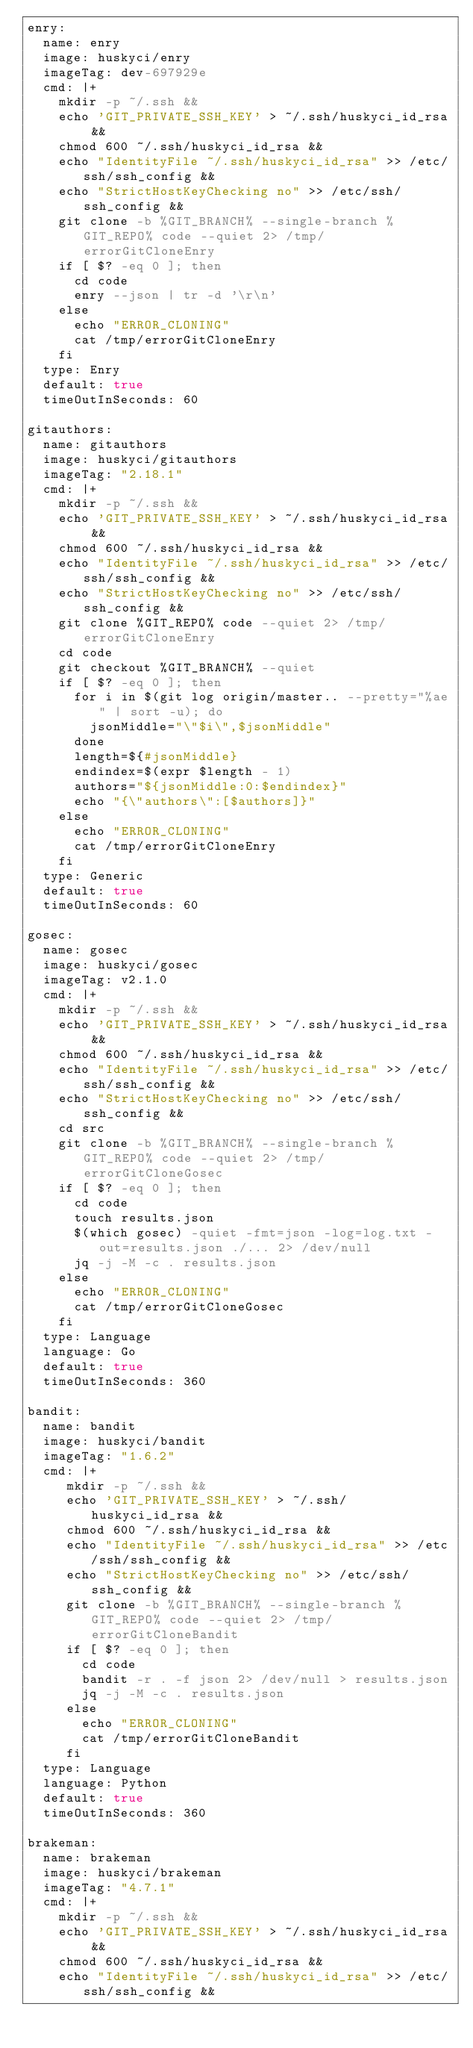<code> <loc_0><loc_0><loc_500><loc_500><_YAML_>enry:
  name: enry
  image: huskyci/enry
  imageTag: dev-697929e
  cmd: |+
    mkdir -p ~/.ssh &&
    echo 'GIT_PRIVATE_SSH_KEY' > ~/.ssh/huskyci_id_rsa &&
    chmod 600 ~/.ssh/huskyci_id_rsa &&
    echo "IdentityFile ~/.ssh/huskyci_id_rsa" >> /etc/ssh/ssh_config &&
    echo "StrictHostKeyChecking no" >> /etc/ssh/ssh_config &&
    git clone -b %GIT_BRANCH% --single-branch %GIT_REPO% code --quiet 2> /tmp/errorGitCloneEnry
    if [ $? -eq 0 ]; then
      cd code
      enry --json | tr -d '\r\n'
    else
      echo "ERROR_CLONING"
      cat /tmp/errorGitCloneEnry
    fi
  type: Enry
  default: true
  timeOutInSeconds: 60

gitauthors:
  name: gitauthors
  image: huskyci/gitauthors
  imageTag: "2.18.1"
  cmd: |+
    mkdir -p ~/.ssh &&
    echo 'GIT_PRIVATE_SSH_KEY' > ~/.ssh/huskyci_id_rsa &&
    chmod 600 ~/.ssh/huskyci_id_rsa &&
    echo "IdentityFile ~/.ssh/huskyci_id_rsa" >> /etc/ssh/ssh_config &&
    echo "StrictHostKeyChecking no" >> /etc/ssh/ssh_config &&
    git clone %GIT_REPO% code --quiet 2> /tmp/errorGitCloneEnry
    cd code
    git checkout %GIT_BRANCH% --quiet
    if [ $? -eq 0 ]; then
      for i in $(git log origin/master.. --pretty="%ae" | sort -u); do
        jsonMiddle="\"$i\",$jsonMiddle"
      done
      length=${#jsonMiddle}
      endindex=$(expr $length - 1)
      authors="${jsonMiddle:0:$endindex}"
      echo "{\"authors\":[$authors]}"
    else
      echo "ERROR_CLONING"
      cat /tmp/errorGitCloneEnry
    fi
  type: Generic
  default: true
  timeOutInSeconds: 60

gosec:
  name: gosec
  image: huskyci/gosec
  imageTag: v2.1.0
  cmd: |+
    mkdir -p ~/.ssh &&
    echo 'GIT_PRIVATE_SSH_KEY' > ~/.ssh/huskyci_id_rsa &&
    chmod 600 ~/.ssh/huskyci_id_rsa &&
    echo "IdentityFile ~/.ssh/huskyci_id_rsa" >> /etc/ssh/ssh_config &&
    echo "StrictHostKeyChecking no" >> /etc/ssh/ssh_config &&
    cd src
    git clone -b %GIT_BRANCH% --single-branch %GIT_REPO% code --quiet 2> /tmp/errorGitCloneGosec
    if [ $? -eq 0 ]; then
      cd code
      touch results.json
      $(which gosec) -quiet -fmt=json -log=log.txt -out=results.json ./... 2> /dev/null
      jq -j -M -c . results.json
    else
      echo "ERROR_CLONING"
      cat /tmp/errorGitCloneGosec
    fi
  type: Language
  language: Go
  default: true
  timeOutInSeconds: 360

bandit:
  name: bandit
  image: huskyci/bandit
  imageTag: "1.6.2"
  cmd: |+
     mkdir -p ~/.ssh &&
     echo 'GIT_PRIVATE_SSH_KEY' > ~/.ssh/huskyci_id_rsa &&
     chmod 600 ~/.ssh/huskyci_id_rsa &&
     echo "IdentityFile ~/.ssh/huskyci_id_rsa" >> /etc/ssh/ssh_config &&
     echo "StrictHostKeyChecking no" >> /etc/ssh/ssh_config &&
     git clone -b %GIT_BRANCH% --single-branch %GIT_REPO% code --quiet 2> /tmp/errorGitCloneBandit
     if [ $? -eq 0 ]; then
       cd code
       bandit -r . -f json 2> /dev/null > results.json
       jq -j -M -c . results.json
     else
       echo "ERROR_CLONING"
       cat /tmp/errorGitCloneBandit
     fi
  type: Language
  language: Python
  default: true
  timeOutInSeconds: 360

brakeman:
  name: brakeman
  image: huskyci/brakeman
  imageTag: "4.7.1"
  cmd: |+
    mkdir -p ~/.ssh &&
    echo 'GIT_PRIVATE_SSH_KEY' > ~/.ssh/huskyci_id_rsa &&
    chmod 600 ~/.ssh/huskyci_id_rsa &&
    echo "IdentityFile ~/.ssh/huskyci_id_rsa" >> /etc/ssh/ssh_config &&</code> 